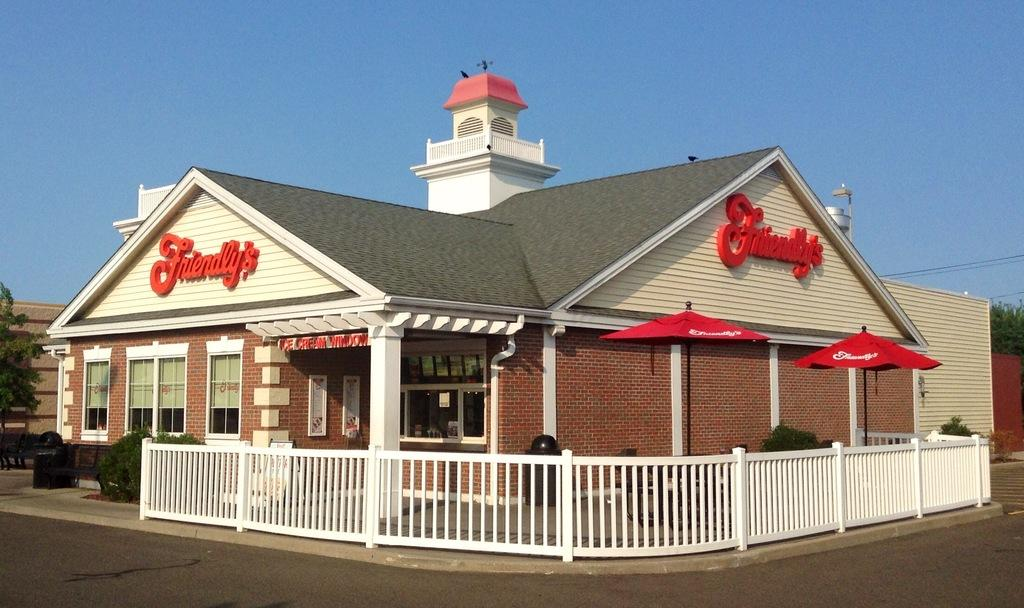<image>
Relay a brief, clear account of the picture shown. A restaurant with a white fence around it called Friendly's. 